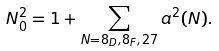Convert formula to latex. <formula><loc_0><loc_0><loc_500><loc_500>N _ { 0 } ^ { 2 } = 1 + \sum _ { N = { 8 _ { D } , 8 _ { F } , 2 7 } } a ^ { 2 } ( N ) .</formula> 